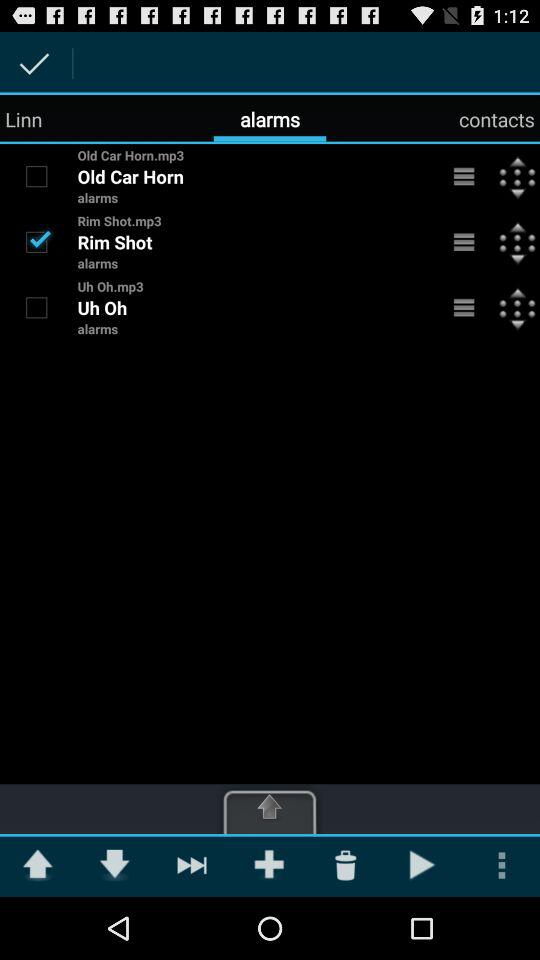Which option is selected? The selected option is "alarms". 